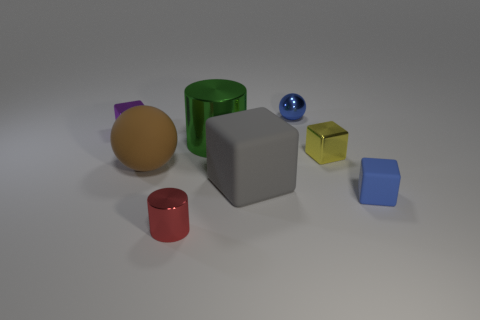Is there anything else that has the same color as the tiny ball?
Your answer should be compact. Yes. What is the material of the object that is the same color as the small sphere?
Ensure brevity in your answer.  Rubber. There is a metal thing that is in front of the rubber cube that is behind the small matte thing; what is its shape?
Ensure brevity in your answer.  Cylinder. Are there any tiny red objects of the same shape as the large green thing?
Keep it short and to the point. Yes. Does the tiny sphere have the same color as the small cube that is in front of the big gray cube?
Your answer should be very brief. Yes. There is a metallic ball that is the same color as the tiny rubber block; what size is it?
Ensure brevity in your answer.  Small. Is there a purple object that has the same size as the blue cube?
Your response must be concise. Yes. Is the material of the blue sphere the same as the ball in front of the purple block?
Give a very brief answer. No. Are there more purple metallic blocks than brown blocks?
Your answer should be very brief. Yes. How many spheres are either tiny green matte things or small yellow shiny objects?
Provide a short and direct response. 0. 